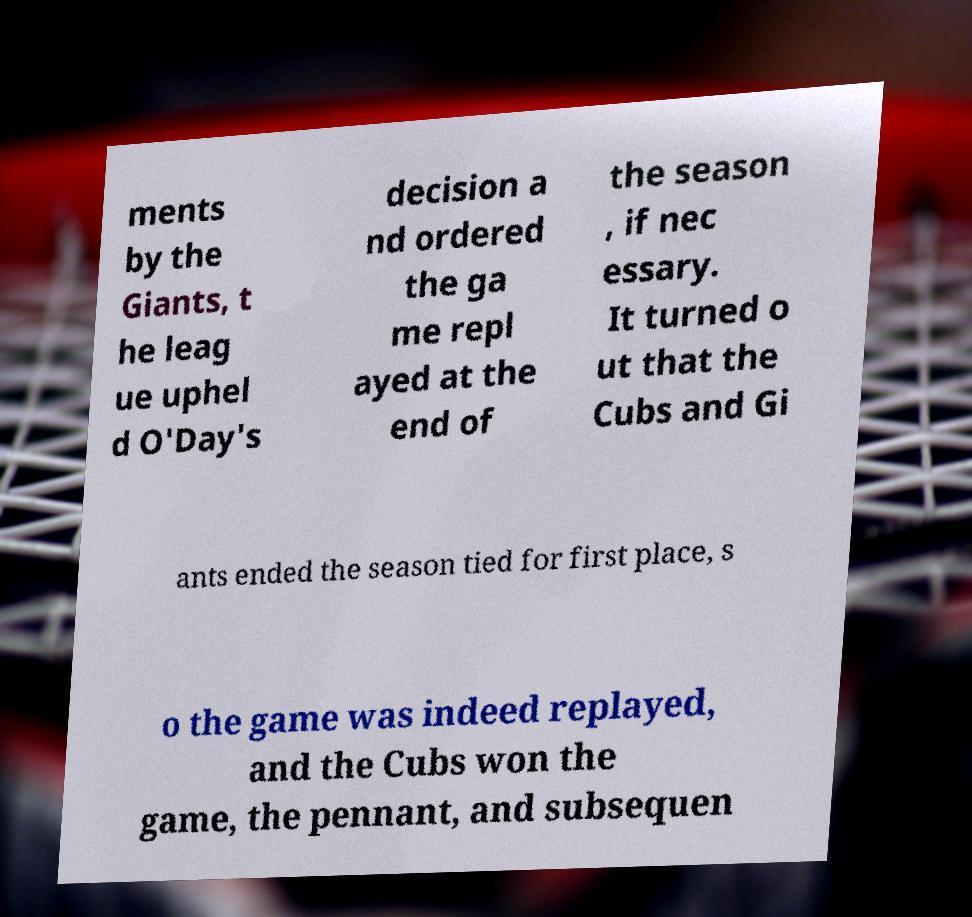Could you assist in decoding the text presented in this image and type it out clearly? ments by the Giants, t he leag ue uphel d O'Day's decision a nd ordered the ga me repl ayed at the end of the season , if nec essary. It turned o ut that the Cubs and Gi ants ended the season tied for first place, s o the game was indeed replayed, and the Cubs won the game, the pennant, and subsequen 